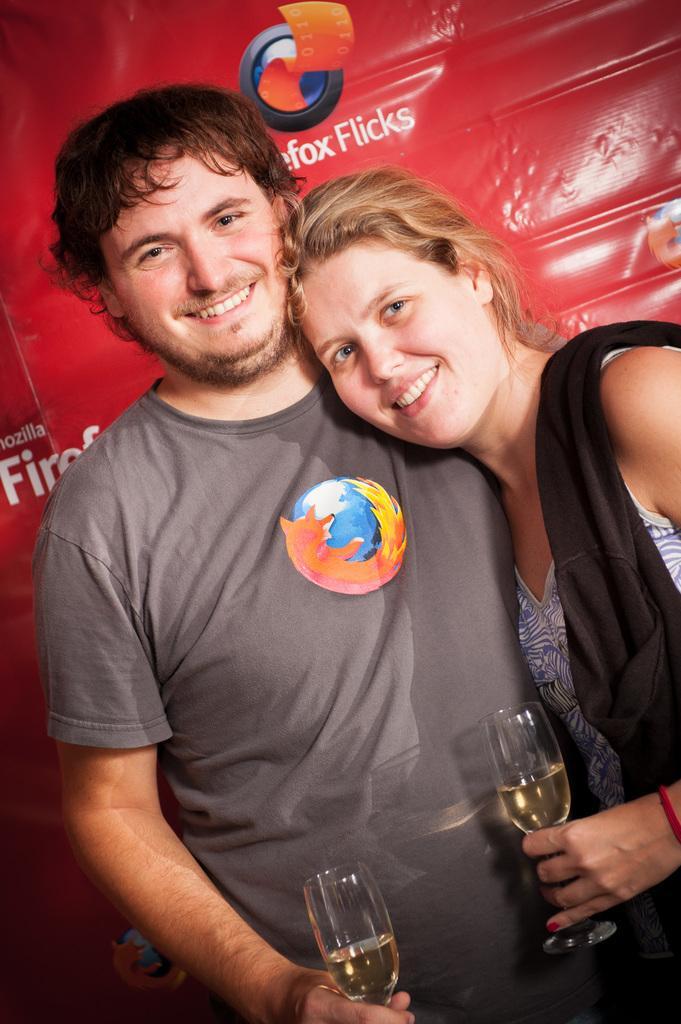Please provide a concise description of this image. A couple are posing to camera with wine glass in their hand. 